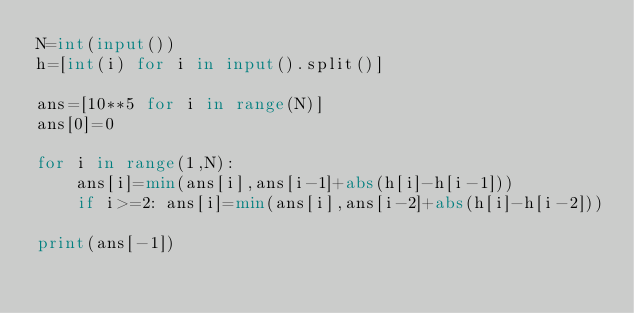<code> <loc_0><loc_0><loc_500><loc_500><_Python_>N=int(input())
h=[int(i) for i in input().split()]

ans=[10**5 for i in range(N)]
ans[0]=0

for i in range(1,N):
    ans[i]=min(ans[i],ans[i-1]+abs(h[i]-h[i-1]))
    if i>=2: ans[i]=min(ans[i],ans[i-2]+abs(h[i]-h[i-2]))

print(ans[-1])
</code> 